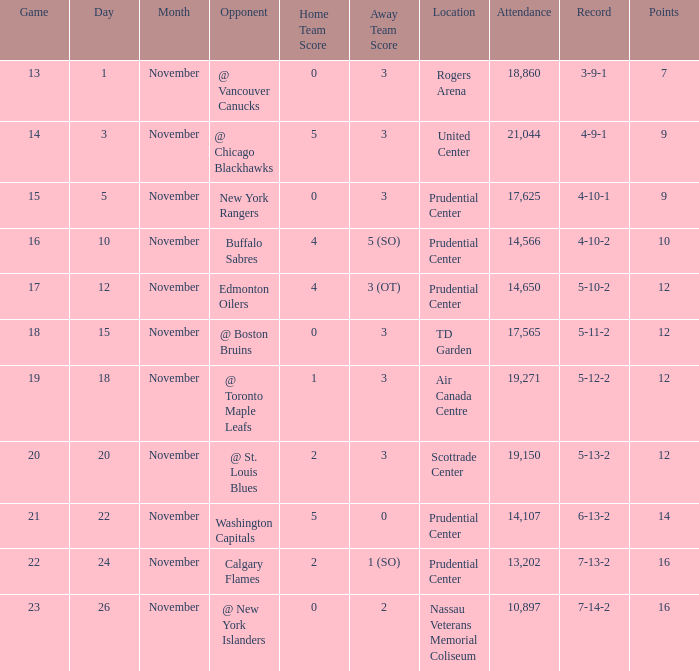What is the record for score 1-3? 5-12-2. 